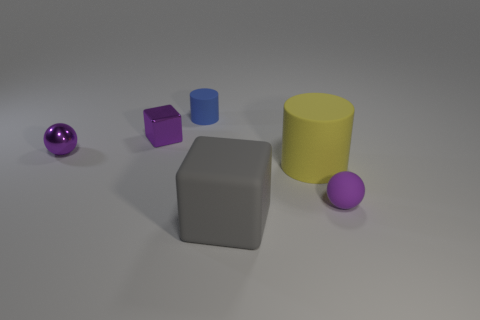Add 2 rubber cylinders. How many objects exist? 8 Subtract all balls. How many objects are left? 4 Add 4 large gray cubes. How many large gray cubes exist? 5 Subtract 0 blue balls. How many objects are left? 6 Subtract all tiny blue things. Subtract all big cylinders. How many objects are left? 4 Add 4 large gray matte objects. How many large gray matte objects are left? 5 